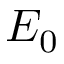<formula> <loc_0><loc_0><loc_500><loc_500>E _ { 0 }</formula> 